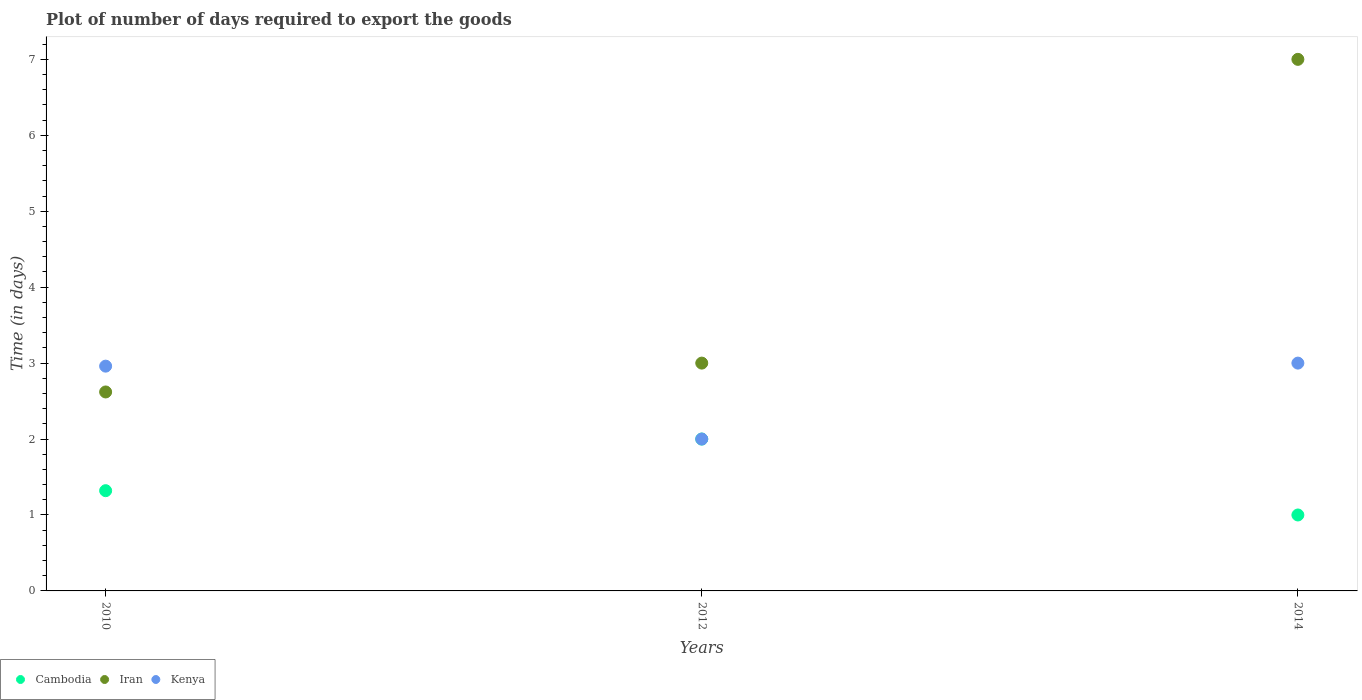How many different coloured dotlines are there?
Your answer should be compact. 3. Across all years, what is the maximum time required to export goods in Kenya?
Offer a very short reply. 3. Across all years, what is the minimum time required to export goods in Iran?
Your answer should be compact. 2.62. In which year was the time required to export goods in Kenya maximum?
Your response must be concise. 2014. In which year was the time required to export goods in Iran minimum?
Your answer should be compact. 2010. What is the total time required to export goods in Iran in the graph?
Keep it short and to the point. 12.62. What is the difference between the time required to export goods in Iran in 2010 and that in 2014?
Keep it short and to the point. -4.38. What is the difference between the time required to export goods in Kenya in 2014 and the time required to export goods in Iran in 2010?
Your answer should be compact. 0.38. What is the average time required to export goods in Cambodia per year?
Your answer should be compact. 1.44. In the year 2010, what is the difference between the time required to export goods in Cambodia and time required to export goods in Iran?
Your answer should be very brief. -1.3. What is the ratio of the time required to export goods in Iran in 2010 to that in 2014?
Make the answer very short. 0.37. Is the time required to export goods in Iran in 2010 less than that in 2014?
Your response must be concise. Yes. In how many years, is the time required to export goods in Cambodia greater than the average time required to export goods in Cambodia taken over all years?
Your answer should be very brief. 1. Is the sum of the time required to export goods in Cambodia in 2012 and 2014 greater than the maximum time required to export goods in Iran across all years?
Make the answer very short. No. How many dotlines are there?
Provide a short and direct response. 3. What is the difference between two consecutive major ticks on the Y-axis?
Keep it short and to the point. 1. Are the values on the major ticks of Y-axis written in scientific E-notation?
Provide a succinct answer. No. Where does the legend appear in the graph?
Offer a very short reply. Bottom left. How many legend labels are there?
Make the answer very short. 3. What is the title of the graph?
Your answer should be very brief. Plot of number of days required to export the goods. Does "Sub-Saharan Africa (developing only)" appear as one of the legend labels in the graph?
Give a very brief answer. No. What is the label or title of the X-axis?
Your response must be concise. Years. What is the label or title of the Y-axis?
Offer a terse response. Time (in days). What is the Time (in days) of Cambodia in 2010?
Offer a very short reply. 1.32. What is the Time (in days) of Iran in 2010?
Keep it short and to the point. 2.62. What is the Time (in days) in Kenya in 2010?
Provide a succinct answer. 2.96. What is the Time (in days) of Iran in 2012?
Make the answer very short. 3. What is the Time (in days) of Iran in 2014?
Offer a very short reply. 7. What is the Time (in days) in Kenya in 2014?
Provide a short and direct response. 3. Across all years, what is the maximum Time (in days) of Cambodia?
Your answer should be compact. 2. Across all years, what is the maximum Time (in days) of Kenya?
Offer a very short reply. 3. Across all years, what is the minimum Time (in days) of Iran?
Your answer should be very brief. 2.62. Across all years, what is the minimum Time (in days) in Kenya?
Ensure brevity in your answer.  2. What is the total Time (in days) of Cambodia in the graph?
Keep it short and to the point. 4.32. What is the total Time (in days) of Iran in the graph?
Offer a very short reply. 12.62. What is the total Time (in days) of Kenya in the graph?
Your response must be concise. 7.96. What is the difference between the Time (in days) in Cambodia in 2010 and that in 2012?
Offer a terse response. -0.68. What is the difference between the Time (in days) of Iran in 2010 and that in 2012?
Keep it short and to the point. -0.38. What is the difference between the Time (in days) in Cambodia in 2010 and that in 2014?
Keep it short and to the point. 0.32. What is the difference between the Time (in days) in Iran in 2010 and that in 2014?
Your answer should be very brief. -4.38. What is the difference between the Time (in days) of Kenya in 2010 and that in 2014?
Keep it short and to the point. -0.04. What is the difference between the Time (in days) in Cambodia in 2012 and that in 2014?
Offer a very short reply. 1. What is the difference between the Time (in days) of Iran in 2012 and that in 2014?
Provide a succinct answer. -4. What is the difference between the Time (in days) of Kenya in 2012 and that in 2014?
Make the answer very short. -1. What is the difference between the Time (in days) of Cambodia in 2010 and the Time (in days) of Iran in 2012?
Your response must be concise. -1.68. What is the difference between the Time (in days) of Cambodia in 2010 and the Time (in days) of Kenya in 2012?
Offer a very short reply. -0.68. What is the difference between the Time (in days) in Iran in 2010 and the Time (in days) in Kenya in 2012?
Provide a succinct answer. 0.62. What is the difference between the Time (in days) of Cambodia in 2010 and the Time (in days) of Iran in 2014?
Offer a very short reply. -5.68. What is the difference between the Time (in days) of Cambodia in 2010 and the Time (in days) of Kenya in 2014?
Offer a terse response. -1.68. What is the difference between the Time (in days) of Iran in 2010 and the Time (in days) of Kenya in 2014?
Provide a succinct answer. -0.38. What is the difference between the Time (in days) of Cambodia in 2012 and the Time (in days) of Iran in 2014?
Your answer should be very brief. -5. What is the difference between the Time (in days) in Cambodia in 2012 and the Time (in days) in Kenya in 2014?
Offer a very short reply. -1. What is the average Time (in days) of Cambodia per year?
Ensure brevity in your answer.  1.44. What is the average Time (in days) in Iran per year?
Give a very brief answer. 4.21. What is the average Time (in days) of Kenya per year?
Your answer should be very brief. 2.65. In the year 2010, what is the difference between the Time (in days) in Cambodia and Time (in days) in Kenya?
Your response must be concise. -1.64. In the year 2010, what is the difference between the Time (in days) in Iran and Time (in days) in Kenya?
Make the answer very short. -0.34. In the year 2012, what is the difference between the Time (in days) in Cambodia and Time (in days) in Iran?
Offer a very short reply. -1. In the year 2012, what is the difference between the Time (in days) in Iran and Time (in days) in Kenya?
Make the answer very short. 1. In the year 2014, what is the difference between the Time (in days) in Cambodia and Time (in days) in Iran?
Keep it short and to the point. -6. In the year 2014, what is the difference between the Time (in days) of Cambodia and Time (in days) of Kenya?
Provide a short and direct response. -2. What is the ratio of the Time (in days) of Cambodia in 2010 to that in 2012?
Offer a very short reply. 0.66. What is the ratio of the Time (in days) of Iran in 2010 to that in 2012?
Provide a succinct answer. 0.87. What is the ratio of the Time (in days) of Kenya in 2010 to that in 2012?
Your answer should be compact. 1.48. What is the ratio of the Time (in days) of Cambodia in 2010 to that in 2014?
Your answer should be compact. 1.32. What is the ratio of the Time (in days) of Iran in 2010 to that in 2014?
Give a very brief answer. 0.37. What is the ratio of the Time (in days) of Kenya in 2010 to that in 2014?
Offer a very short reply. 0.99. What is the ratio of the Time (in days) in Iran in 2012 to that in 2014?
Provide a short and direct response. 0.43. What is the difference between the highest and the second highest Time (in days) of Cambodia?
Ensure brevity in your answer.  0.68. What is the difference between the highest and the lowest Time (in days) of Iran?
Provide a succinct answer. 4.38. What is the difference between the highest and the lowest Time (in days) in Kenya?
Your answer should be very brief. 1. 